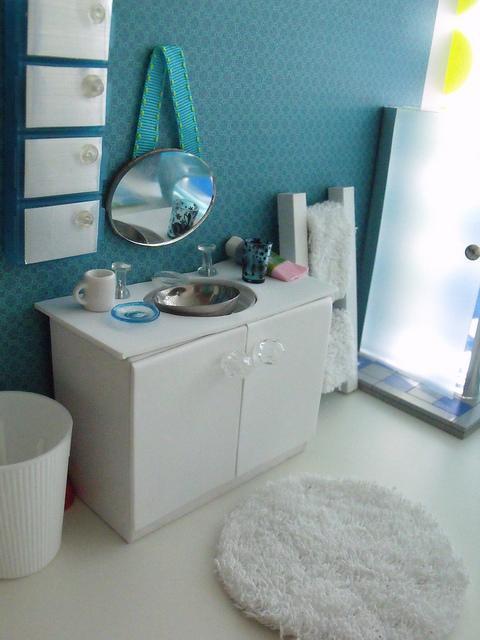How many people are wearing red shirts?
Give a very brief answer. 0. 